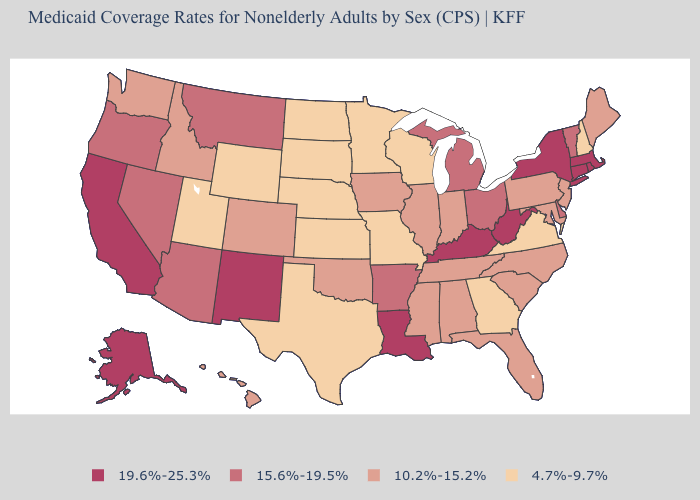Is the legend a continuous bar?
Be succinct. No. What is the highest value in the Northeast ?
Short answer required. 19.6%-25.3%. What is the value of Rhode Island?
Keep it brief. 19.6%-25.3%. Among the states that border Kansas , which have the highest value?
Give a very brief answer. Colorado, Oklahoma. What is the value of West Virginia?
Write a very short answer. 19.6%-25.3%. Does Connecticut have the highest value in the USA?
Quick response, please. Yes. Name the states that have a value in the range 10.2%-15.2%?
Quick response, please. Alabama, Colorado, Florida, Hawaii, Idaho, Illinois, Indiana, Iowa, Maine, Maryland, Mississippi, New Jersey, North Carolina, Oklahoma, Pennsylvania, South Carolina, Tennessee, Washington. Does North Dakota have the lowest value in the MidWest?
Short answer required. Yes. Does Ohio have the highest value in the MidWest?
Be succinct. Yes. Does Louisiana have the highest value in the South?
Keep it brief. Yes. Does the map have missing data?
Keep it brief. No. What is the highest value in the Northeast ?
Be succinct. 19.6%-25.3%. Does North Dakota have the lowest value in the USA?
Be succinct. Yes. Among the states that border Idaho , does Nevada have the lowest value?
Short answer required. No. Is the legend a continuous bar?
Give a very brief answer. No. 